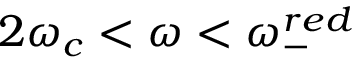<formula> <loc_0><loc_0><loc_500><loc_500>2 \omega _ { c } < \omega < \omega _ { - } ^ { r e d }</formula> 